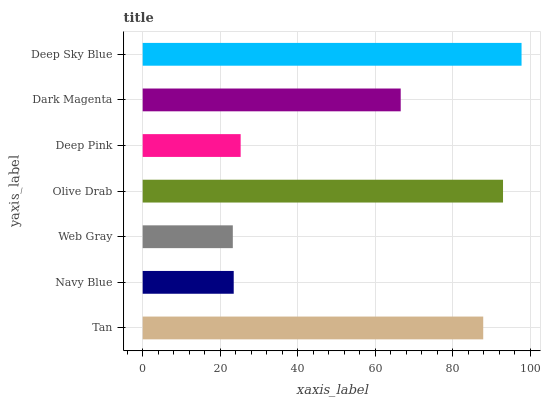Is Web Gray the minimum?
Answer yes or no. Yes. Is Deep Sky Blue the maximum?
Answer yes or no. Yes. Is Navy Blue the minimum?
Answer yes or no. No. Is Navy Blue the maximum?
Answer yes or no. No. Is Tan greater than Navy Blue?
Answer yes or no. Yes. Is Navy Blue less than Tan?
Answer yes or no. Yes. Is Navy Blue greater than Tan?
Answer yes or no. No. Is Tan less than Navy Blue?
Answer yes or no. No. Is Dark Magenta the high median?
Answer yes or no. Yes. Is Dark Magenta the low median?
Answer yes or no. Yes. Is Web Gray the high median?
Answer yes or no. No. Is Tan the low median?
Answer yes or no. No. 